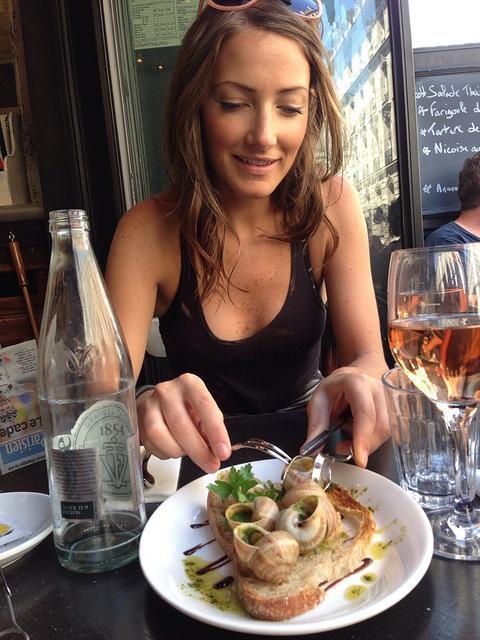What country are they in?
From the following four choices, select the correct answer to address the question.
Options: France, portugal, england, spain. France. 